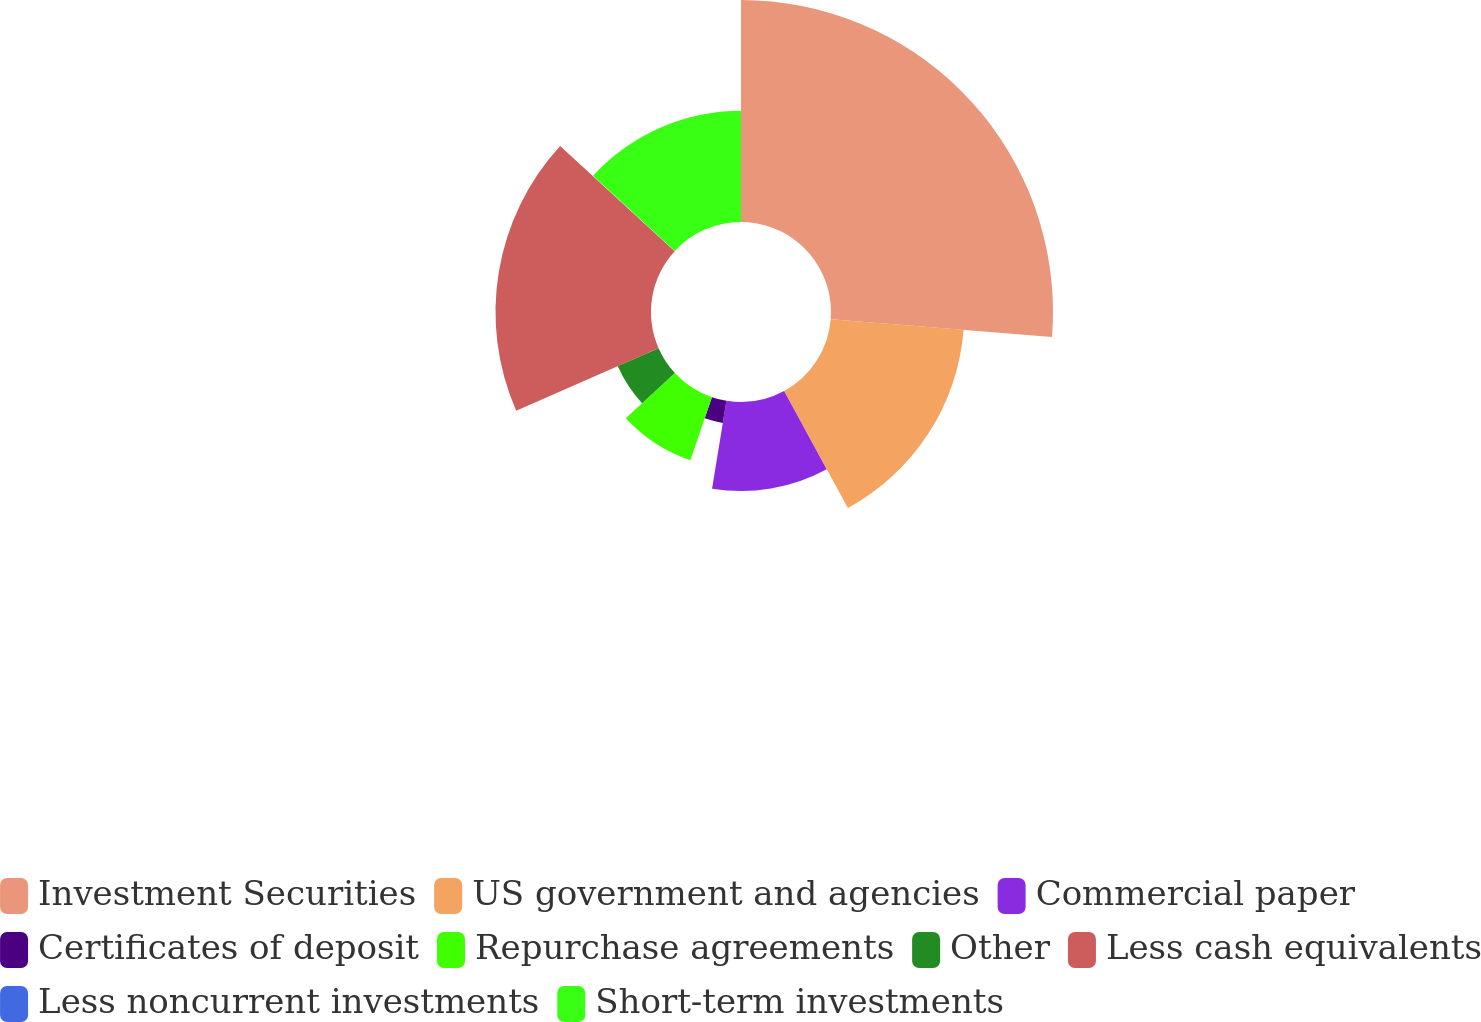Convert chart to OTSL. <chart><loc_0><loc_0><loc_500><loc_500><pie_chart><fcel>Investment Securities<fcel>US government and agencies<fcel>Commercial paper<fcel>Certificates of deposit<fcel>Repurchase agreements<fcel>Other<fcel>Less cash equivalents<fcel>Less noncurrent investments<fcel>Short-term investments<nl><fcel>26.27%<fcel>15.78%<fcel>10.53%<fcel>2.65%<fcel>7.9%<fcel>5.28%<fcel>18.4%<fcel>0.03%<fcel>13.15%<nl></chart> 